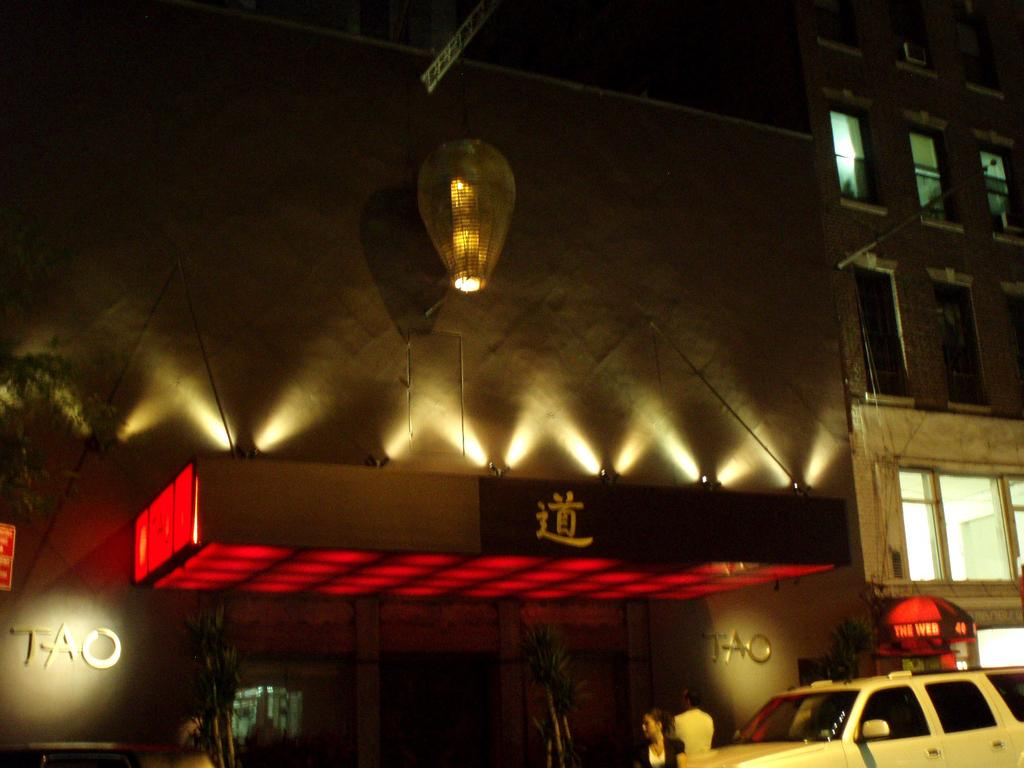<image>
Share a concise interpretation of the image provided. The outside of a nightclub at night with the word TAO written on it. 